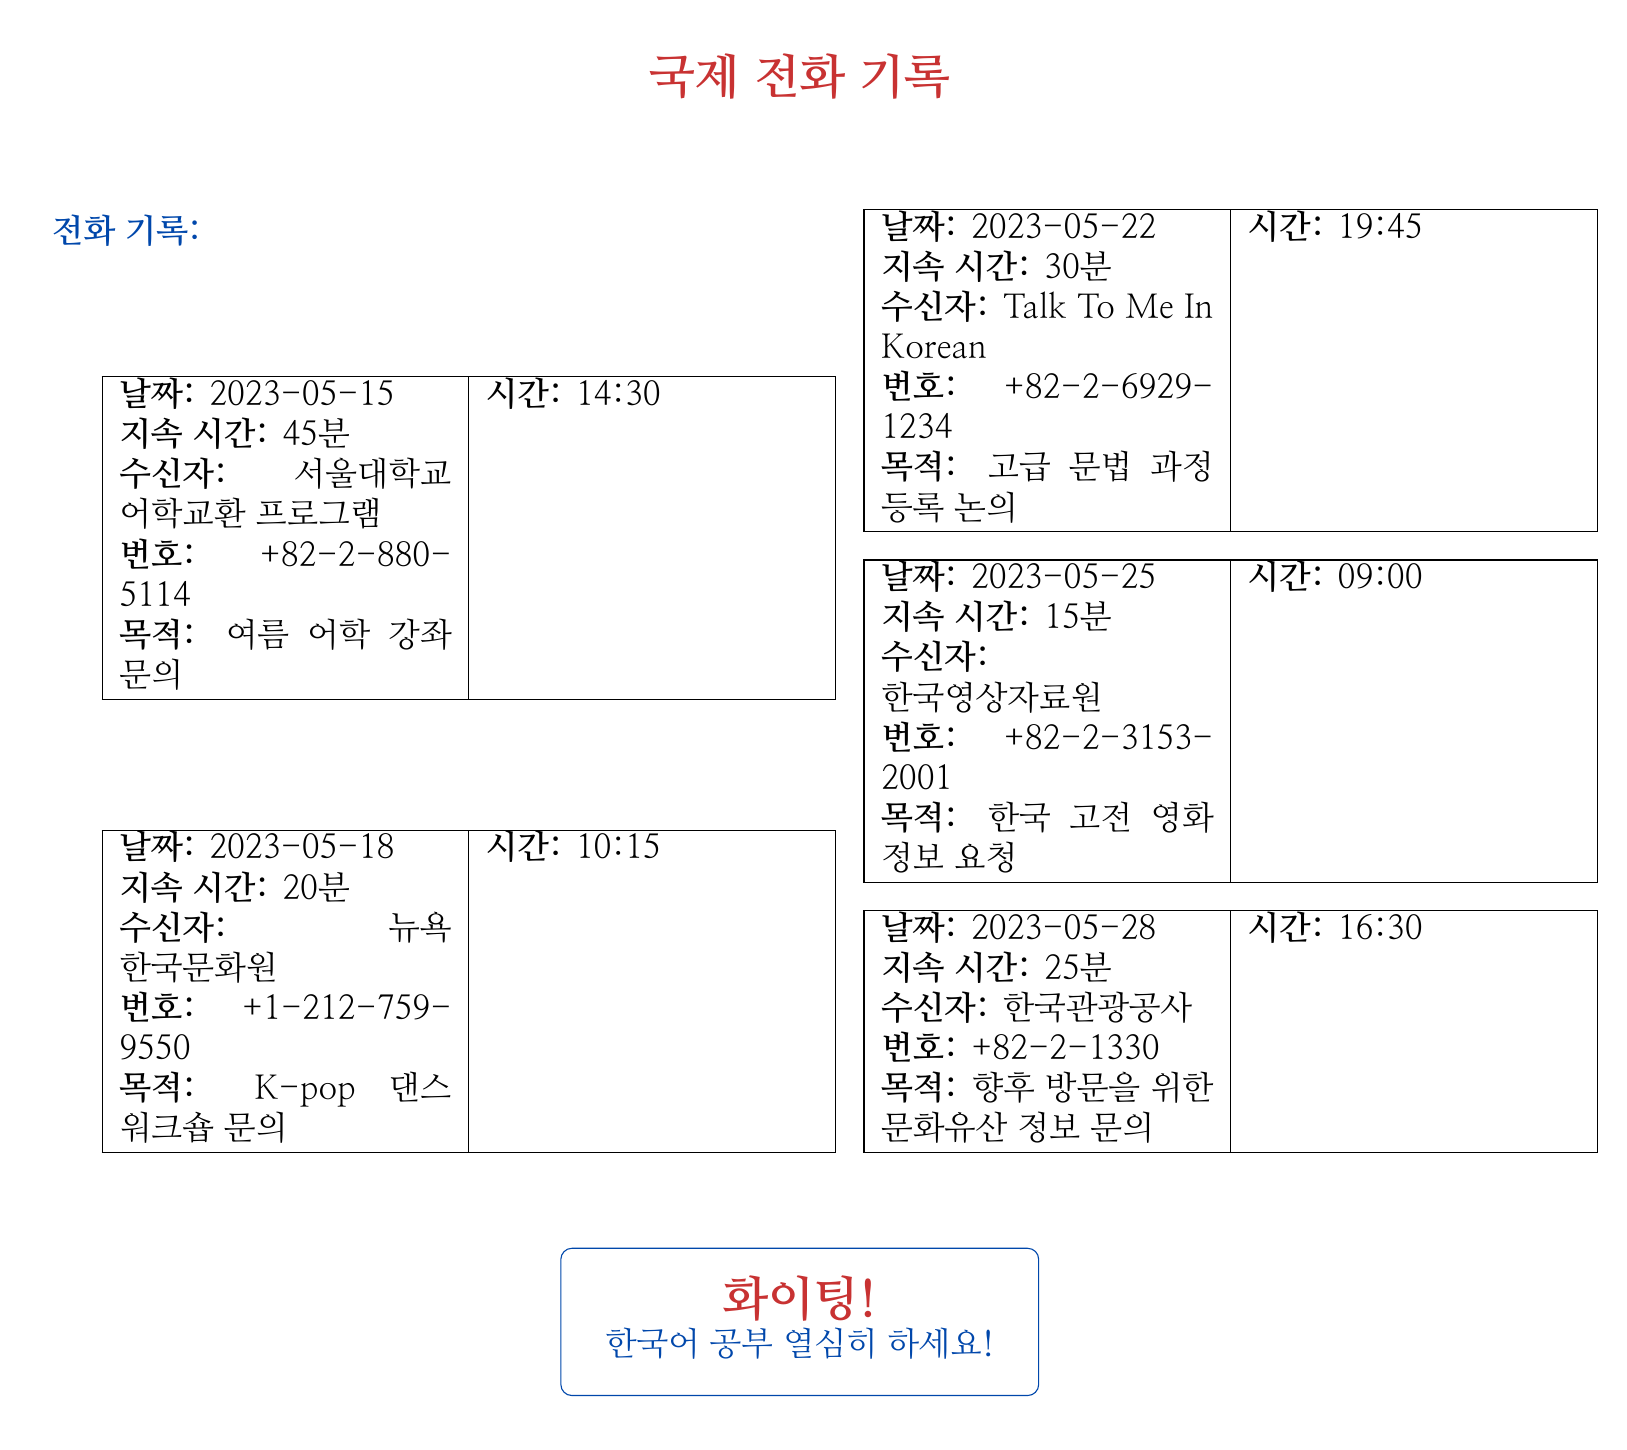what is the date of the first call? The first call listed in the document was made on May 15, 2023.
Answer: 2023-05-15 who was the recipient of the second call? The recipient of the second call was the 뉴욕 한국문화원 (New York Korean Cultural Center).
Answer: 뉴욕 한국문화원 what was the purpose of the call made on May 25? The purpose of the call on May 25 was to request information about Korean classic films.
Answer: 한국 고전 영화 정보 요청 how long was the call to Talk To Me In Korean? The call to Talk To Me In Korean lasted for 30 minutes.
Answer: 30분 what is the phone number for the 서울대학교 어학교환 프로그램? The phone number for the 서울대학교 어학교환 프로그램 is +82-2-880-5114.
Answer: +82-2-880-5114 which organization was contacted regarding a K-pop dance workshop? The organization contacted about the K-pop dance workshop was the 뉴욕 한국문화원 (New York Korean Cultural Center).
Answer: 뉴욕 한국문화원 how many calls were made in total? The document contains five separate calls listed.
Answer: 5 what is the time of the call on May 28? The call on May 28 was made at 16:30.
Answer: 16:30 what type of document is this? The document contains records of international phone calls regarding cultural research and language practice.
Answer: 전화 기록 